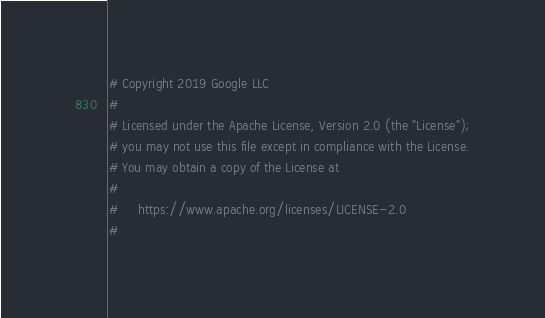<code> <loc_0><loc_0><loc_500><loc_500><_Python_># Copyright 2019 Google LLC
#
# Licensed under the Apache License, Version 2.0 (the "License");
# you may not use this file except in compliance with the License.
# You may obtain a copy of the License at
#
#     https://www.apache.org/licenses/LICENSE-2.0
#</code> 